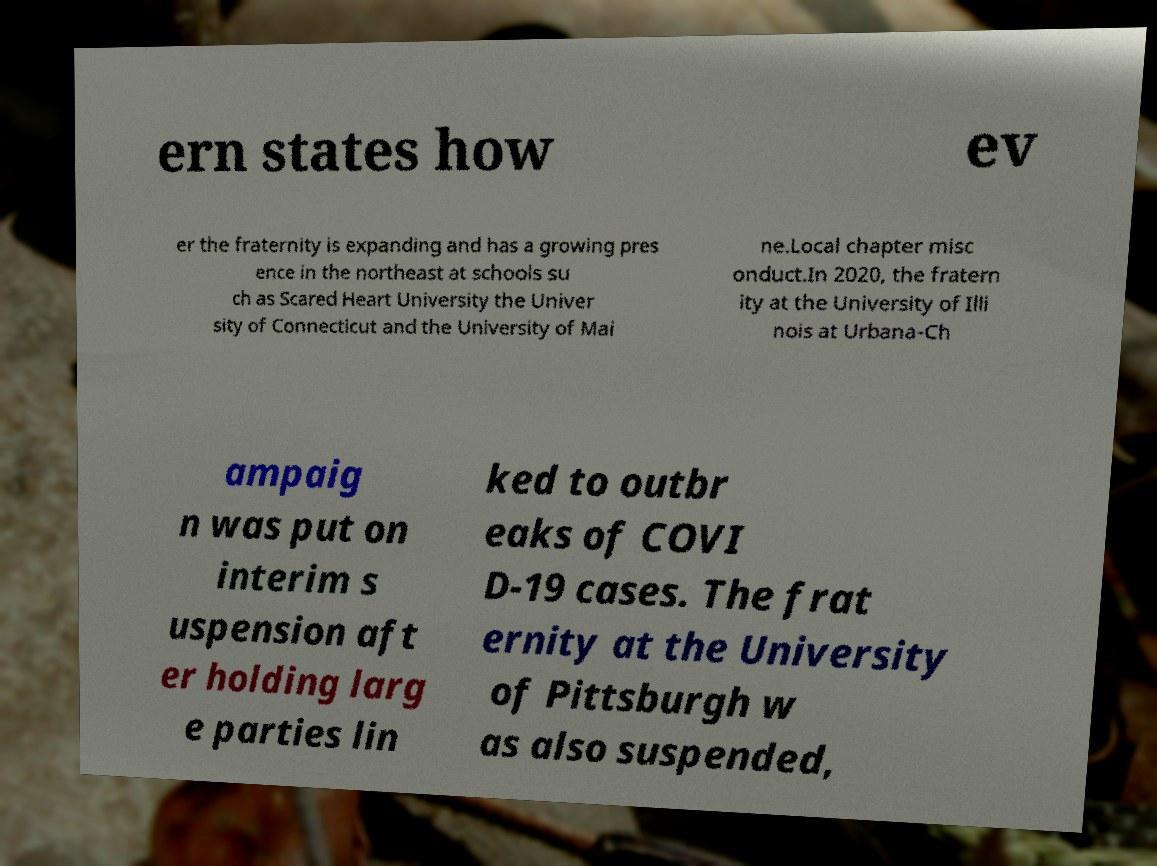For documentation purposes, I need the text within this image transcribed. Could you provide that? ern states how ev er the fraternity is expanding and has a growing pres ence in the northeast at schools su ch as Scared Heart University the Univer sity of Connecticut and the University of Mai ne.Local chapter misc onduct.In 2020, the fratern ity at the University of Illi nois at Urbana-Ch ampaig n was put on interim s uspension aft er holding larg e parties lin ked to outbr eaks of COVI D-19 cases. The frat ernity at the University of Pittsburgh w as also suspended, 